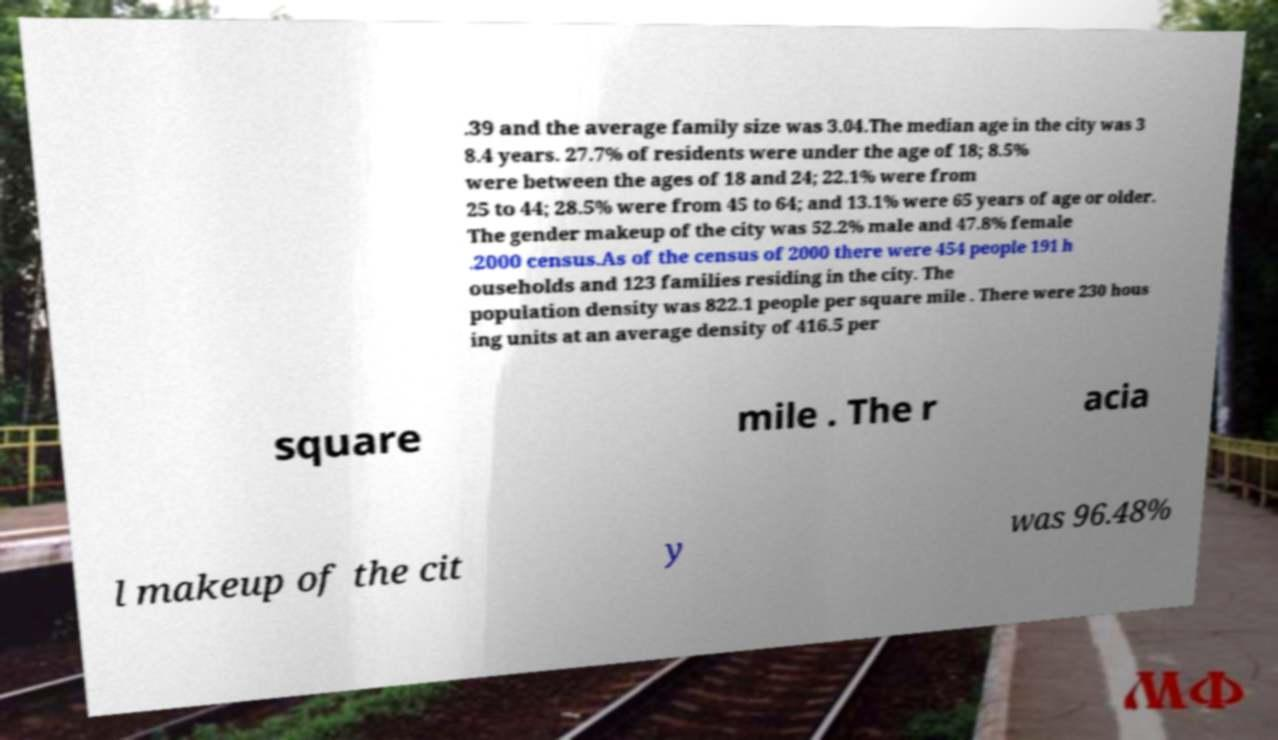I need the written content from this picture converted into text. Can you do that? .39 and the average family size was 3.04.The median age in the city was 3 8.4 years. 27.7% of residents were under the age of 18; 8.5% were between the ages of 18 and 24; 22.1% were from 25 to 44; 28.5% were from 45 to 64; and 13.1% were 65 years of age or older. The gender makeup of the city was 52.2% male and 47.8% female .2000 census.As of the census of 2000 there were 454 people 191 h ouseholds and 123 families residing in the city. The population density was 822.1 people per square mile . There were 230 hous ing units at an average density of 416.5 per square mile . The r acia l makeup of the cit y was 96.48% 